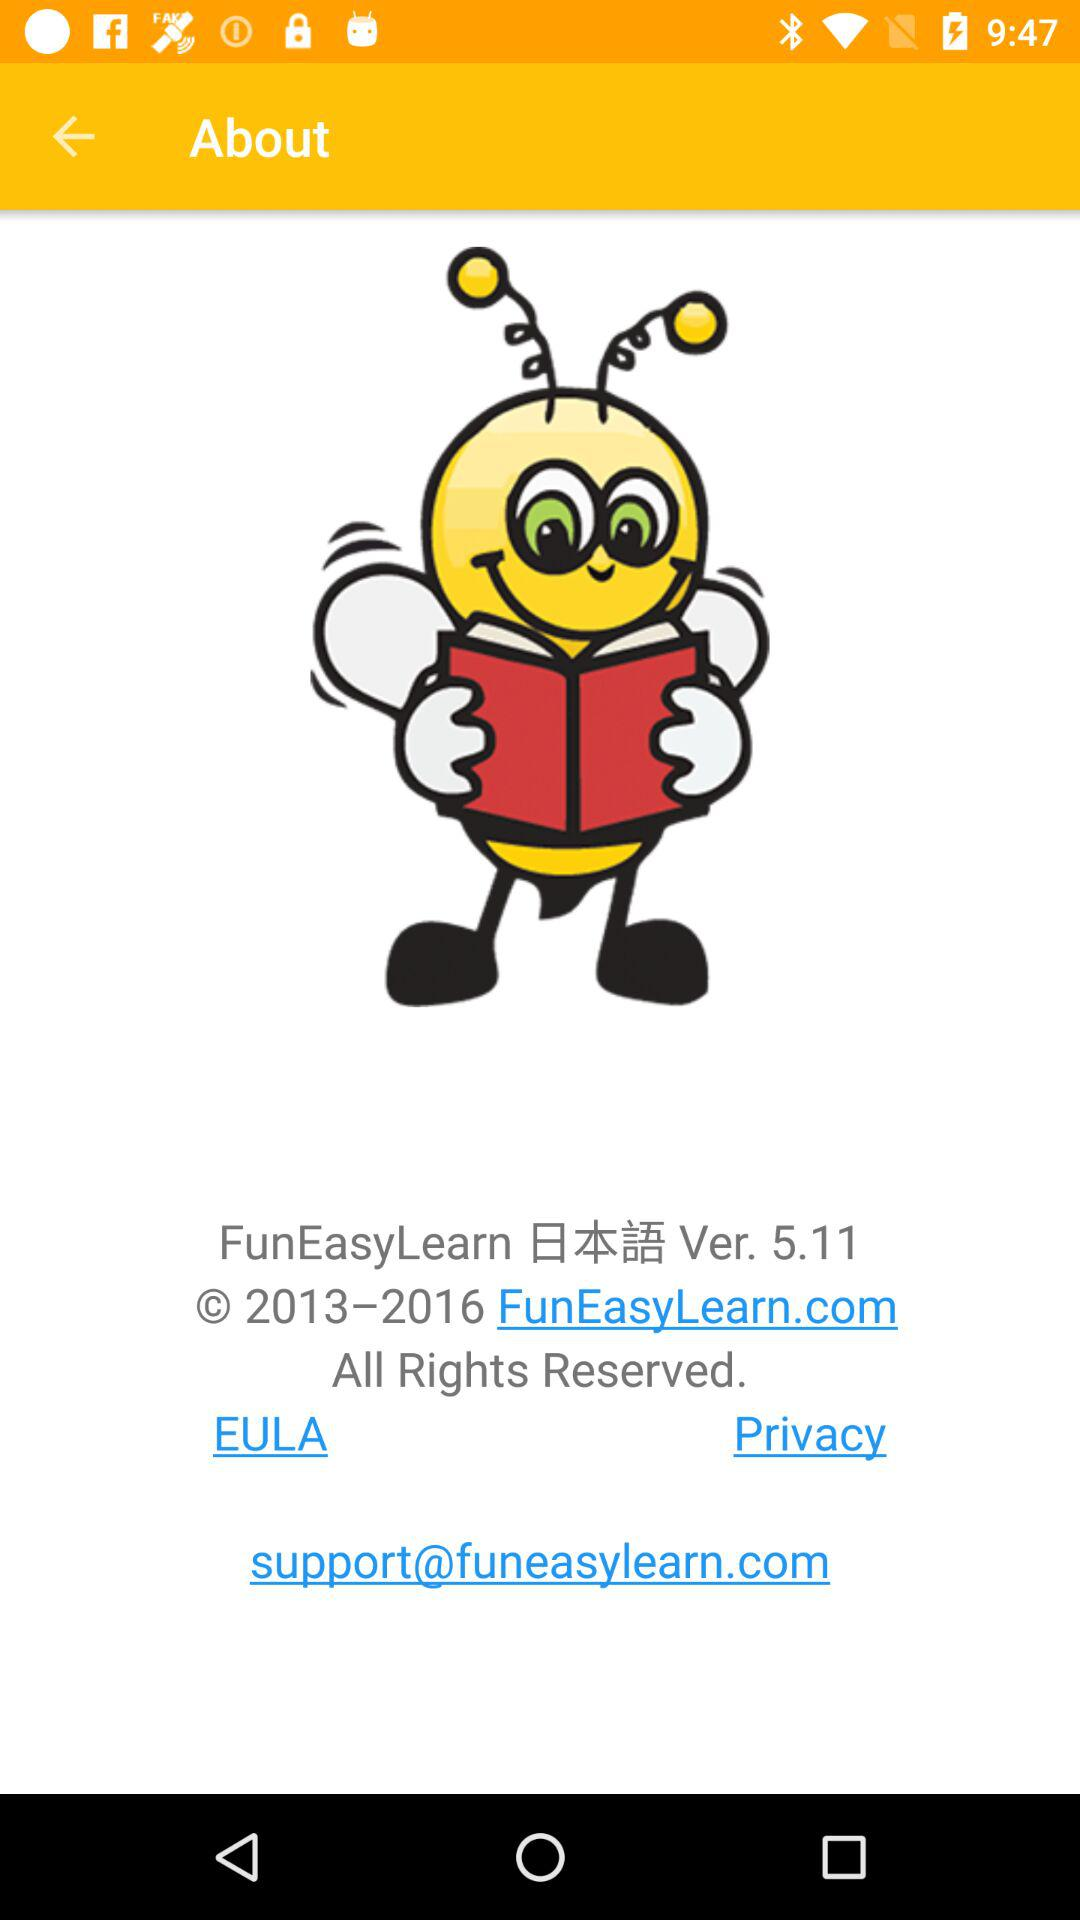How many years does the copyright cover?
Answer the question using a single word or phrase. 3 